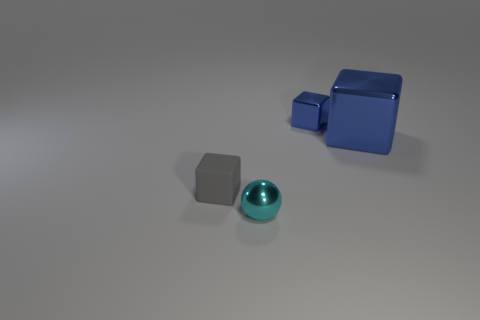There is a shiny object that is in front of the metal block that is in front of the block that is behind the big blue shiny block; what is its size?
Offer a terse response. Small. There is a tiny gray thing; are there any gray matte cubes behind it?
Keep it short and to the point. No. What shape is the other metallic object that is the same color as the large object?
Your response must be concise. Cube. How many objects are shiny objects in front of the large cube or big blue matte cubes?
Keep it short and to the point. 1. What size is the cyan object that is made of the same material as the tiny blue cube?
Keep it short and to the point. Small. Is the size of the gray rubber cube the same as the metallic thing that is in front of the small gray block?
Ensure brevity in your answer.  Yes. What is the color of the thing that is both behind the small ball and in front of the big blue metal block?
Your answer should be compact. Gray. How many things are things that are behind the ball or small objects that are behind the tiny ball?
Give a very brief answer. 3. There is a tiny thing that is behind the small block that is left of the tiny blue shiny block that is right of the small cyan shiny sphere; what color is it?
Provide a succinct answer. Blue. Is there a tiny cyan thing that has the same shape as the small blue thing?
Keep it short and to the point. No. 